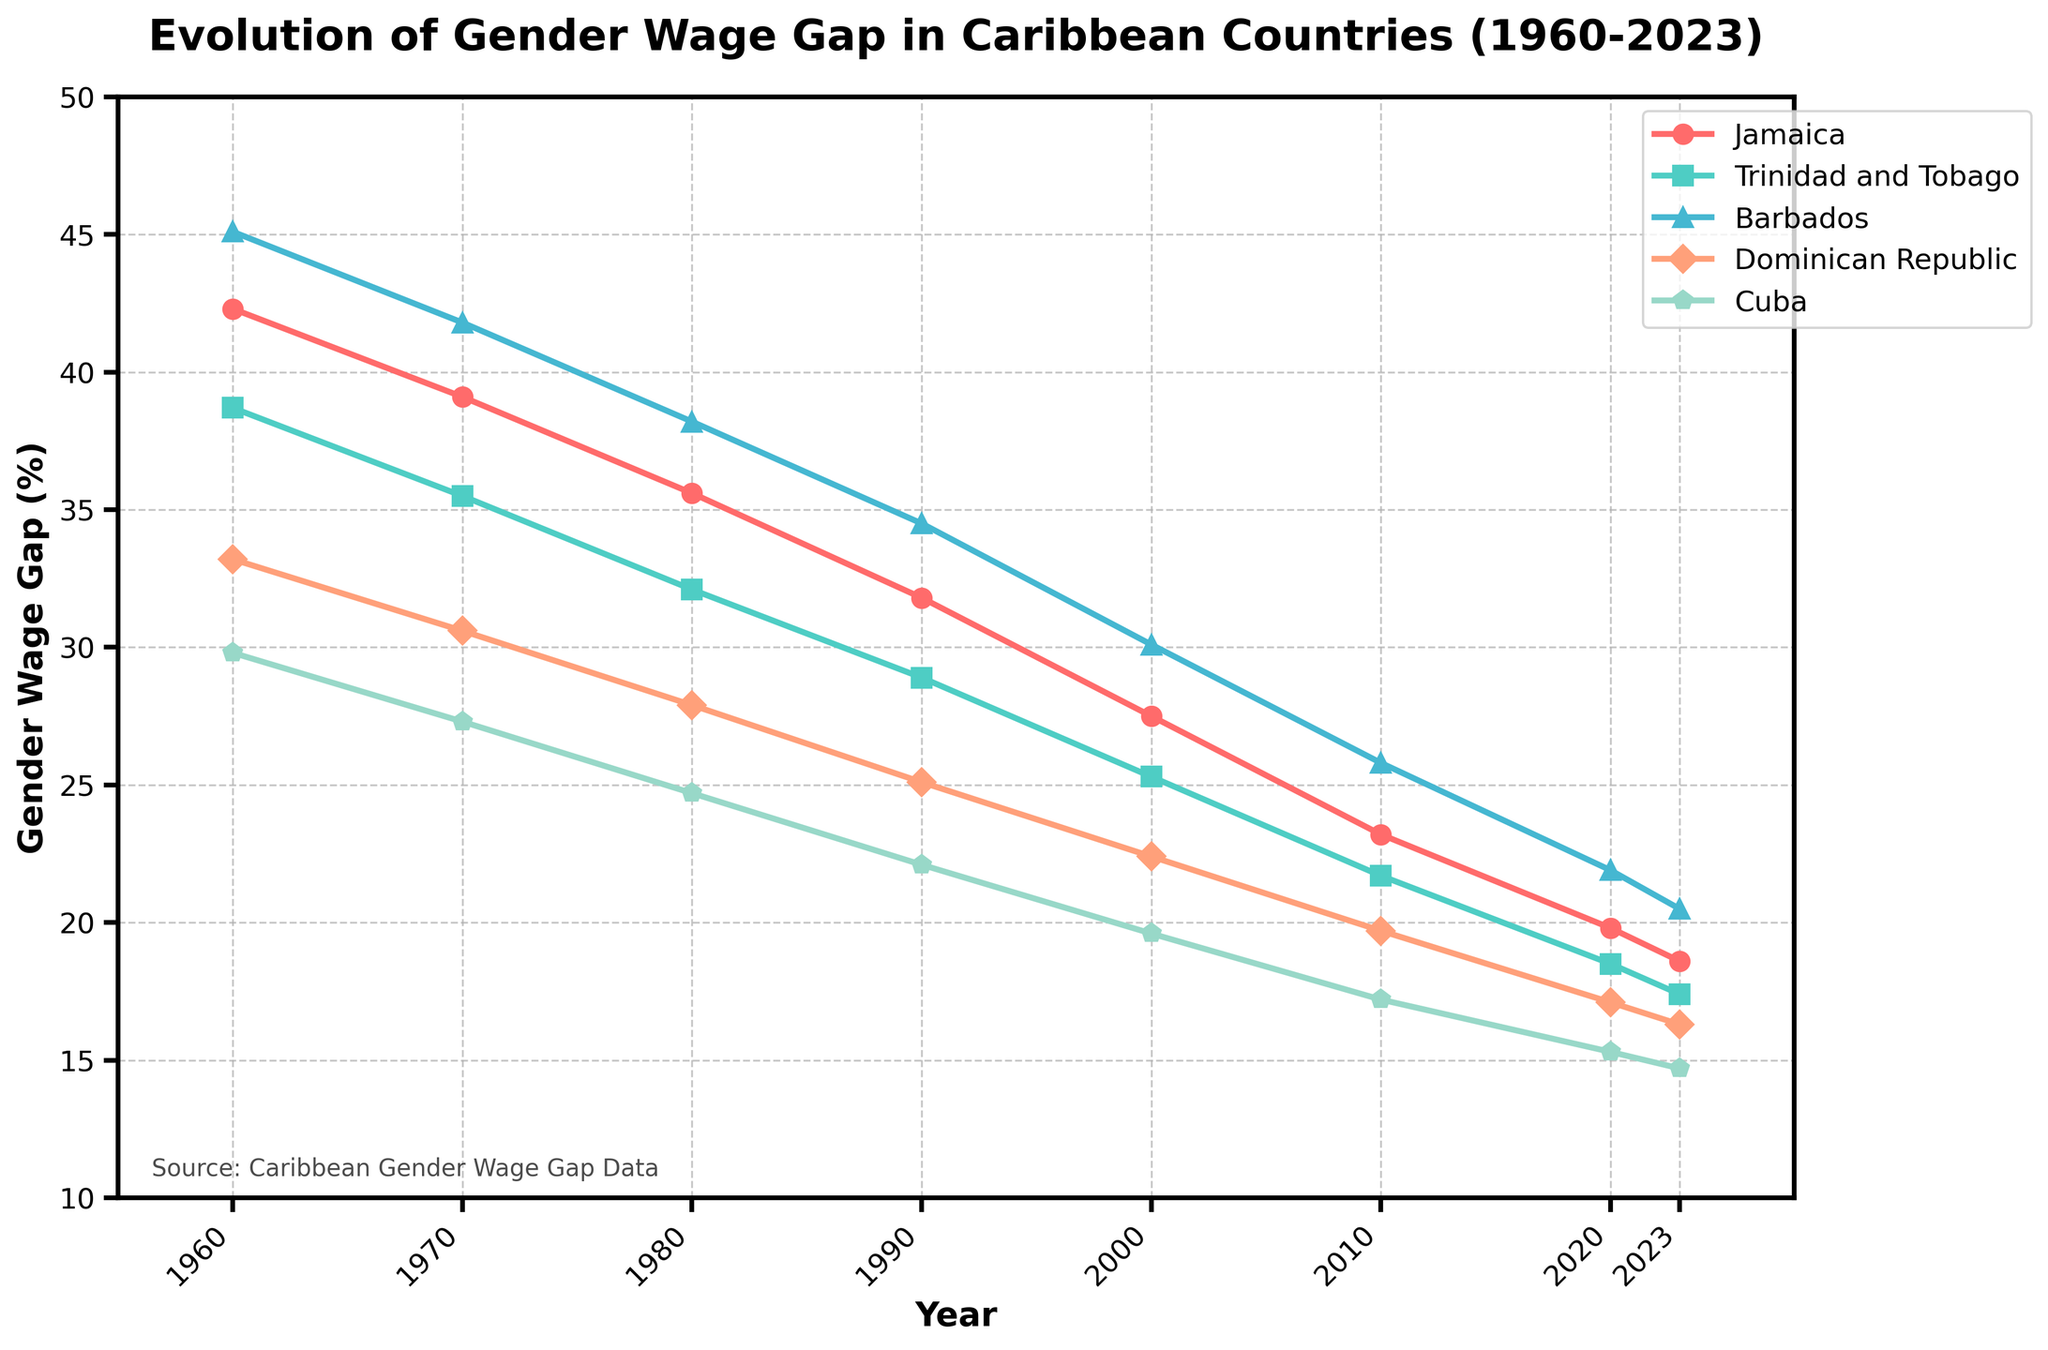Which country shows the largest reduction in the gender wage gap from 1960 to 2023? To find the largest reduction, subtract the 2023 value from the 1960 value for each country, and compare the results. Jamaica: 42.3 - 18.6 = 23.7, Trinidad and Tobago: 38.7 - 17.4 = 21.3, Barbados: 45.1 - 20.5 = 24.6, Dominican Republic: 33.2 - 16.3 = 16.9, Cuba: 29.8 - 14.7 = 15.1. Barbados has the largest reduction with 24.6.
Answer: Barbados By how many percentage points did the gender wage gap in Cuba change between 2000 and 2023? Subtract the 2023 value from the 2000 value for Cuba: 19.6 - 14.7 = 4.9.
Answer: 4.9 Which country had the smallest gender wage gap in 2020, and what was the value? Look at the 2020 data values for all countries and find the smallest one: Jamaica: 19.8, Trinidad and Tobago: 18.5, Barbados: 21.9, Dominican Republic: 17.1, Cuba: 15.3. Cuba had the smallest gap, which was 15.3.
Answer: Cuba, 15.3 Compare the trend of the gender wage gap in Jamaica and Dominican Republic between 1960 and 2023. Which country shows a steeper decline? Calculate the decline for each country:  Jamaica: 42.3 - 18.6 = 23.7, Dominican Republic: 33.2 - 16.3 = 16.9. Jamaica shows a steeper decline since 23.7 is greater than 16.9.
Answer: Jamaica What is the average gender wage gap for Trinidad and Tobago across all recorded years? Sum all values for Trinidad and Tobago and divide by the number of years: (38.7 + 35.5 + 32.1 + 28.9 + 25.3 + 21.7 + 18.5 + 17.4) / 8 = 27.26
Answer: 27.26 Between 1980 and 2000, which country experienced the largest reduction in the gender wage gap? Subtract the 2000 value from the 1980 value for each country: Jamaica: 35.6 - 27.5 = 8.1, Trinidad and Tobago: 32.1 - 25.3 = 6.8, Barbados: 38.2 - 30.1 = 8.1, Dominican Republic: 27.9 - 22.4 = 5.5, Cuba: 24.7 - 19.6 = 5.1. Both Jamaica and Barbados experienced the largest reduction of 8.1 percentage points.
Answer: Jamaica and Barbados In which year did Trinidad and Tobago’s gender wage gap first drop below 30%? Check the values for each year: 1960: 38.7, 1970: 35.5, 1980: 32.1, 1990: 28.9. It first drops below 30% in 1990.
Answer: 1990 What visual pattern do you see regarding the evolution of the gender wage gap in these Caribbean countries from 1960 to 2023? Observing the chart, all five countries demonstrate a consistent downward trend in the gender wage gap over time, with fluctuations.
Answer: Consistent downward trend Which country had the highest gender wage gap in 1960, and by how much was it higher than the country with the lowest gap? Compare all values for 1960: Jamaica: 42.3, Trinidad and Tobago: 38.7, Barbados: 45.1, Dominican Republic: 33.2, Cuba: 29.8. Barbados had the highest, and Cuba had the lowest: 45.1 - 29.8 = 15.3.
Answer: Barbados, 15.3 By which year did Jamaica’s gender wage gap decrease to below 20%? Observe the values for Jamaica to identify the first year the gap goes below 20%: 1960: 42.3, 1970: 39.1, 1980: 35.6, 1990: 31.8, 2000: 27.5, 2010: 23.2, 2020: 19.8. It is in 2020.
Answer: 2020 